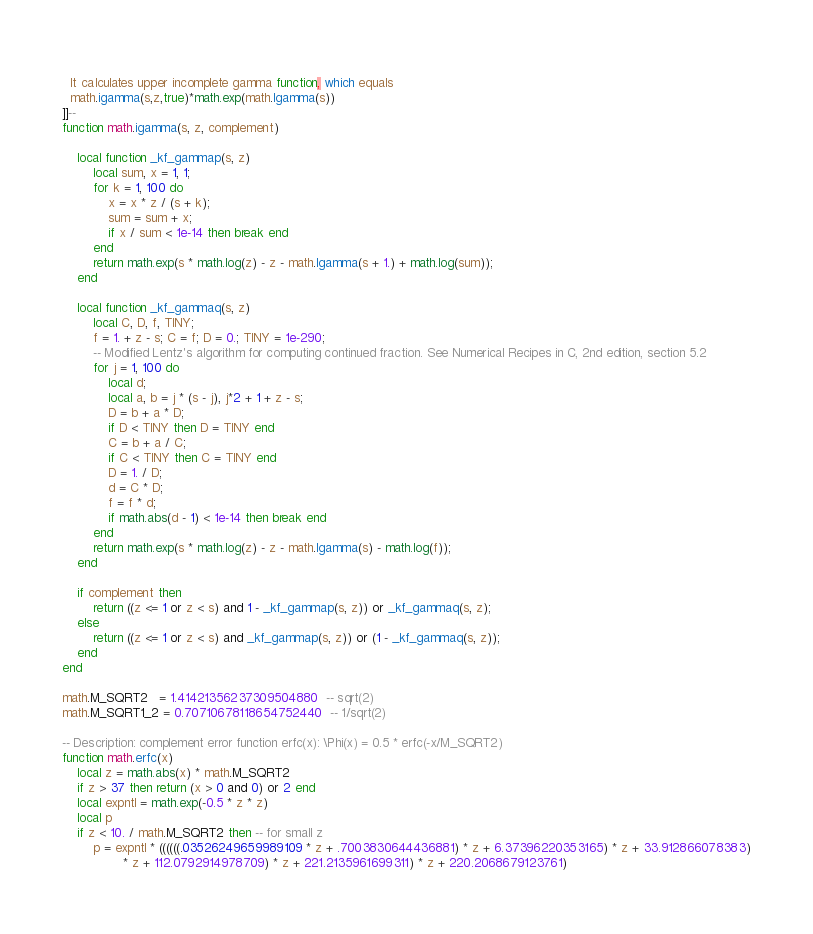Convert code to text. <code><loc_0><loc_0><loc_500><loc_500><_Lua_> 
  It calculates upper incomplete gamma function, which equals
  math.igamma(s,z,true)*math.exp(math.lgamma(s))
]]--
function math.igamma(s, z, complement)

	local function _kf_gammap(s, z)
		local sum, x = 1, 1;
		for k = 1, 100 do
			x = x * z / (s + k);
			sum = sum + x;
			if x / sum < 1e-14 then break end
		end
		return math.exp(s * math.log(z) - z - math.lgamma(s + 1.) + math.log(sum));
	end

	local function _kf_gammaq(s, z)
		local C, D, f, TINY;
		f = 1. + z - s; C = f; D = 0.; TINY = 1e-290;
		-- Modified Lentz's algorithm for computing continued fraction. See Numerical Recipes in C, 2nd edition, section 5.2
		for j = 1, 100 do
			local d;
			local a, b = j * (s - j), j*2 + 1 + z - s;
			D = b + a * D;
			if D < TINY then D = TINY end
			C = b + a / C;
			if C < TINY then C = TINY end
			D = 1. / D;
			d = C * D;
			f = f * d;
			if math.abs(d - 1) < 1e-14 then break end
		end
		return math.exp(s * math.log(z) - z - math.lgamma(s) - math.log(f));
	end

	if complement then
		return ((z <= 1 or z < s) and 1 - _kf_gammap(s, z)) or _kf_gammaq(s, z);
	else 
		return ((z <= 1 or z < s) and _kf_gammap(s, z)) or (1 - _kf_gammaq(s, z));
	end
end

math.M_SQRT2   = 1.41421356237309504880  -- sqrt(2)
math.M_SQRT1_2 = 0.70710678118654752440  -- 1/sqrt(2)

-- Description: complement error function erfc(x): \Phi(x) = 0.5 * erfc(-x/M_SQRT2)
function math.erfc(x)
	local z = math.abs(x) * math.M_SQRT2
	if z > 37 then return (x > 0 and 0) or 2 end
	local expntl = math.exp(-0.5 * z * z)
	local p
	if z < 10. / math.M_SQRT2 then -- for small z
	    p = expntl * ((((((.03526249659989109 * z + .7003830644436881) * z + 6.37396220353165) * z + 33.912866078383)
				* z + 112.0792914978709) * z + 221.2135961699311) * z + 220.2068679123761)</code> 